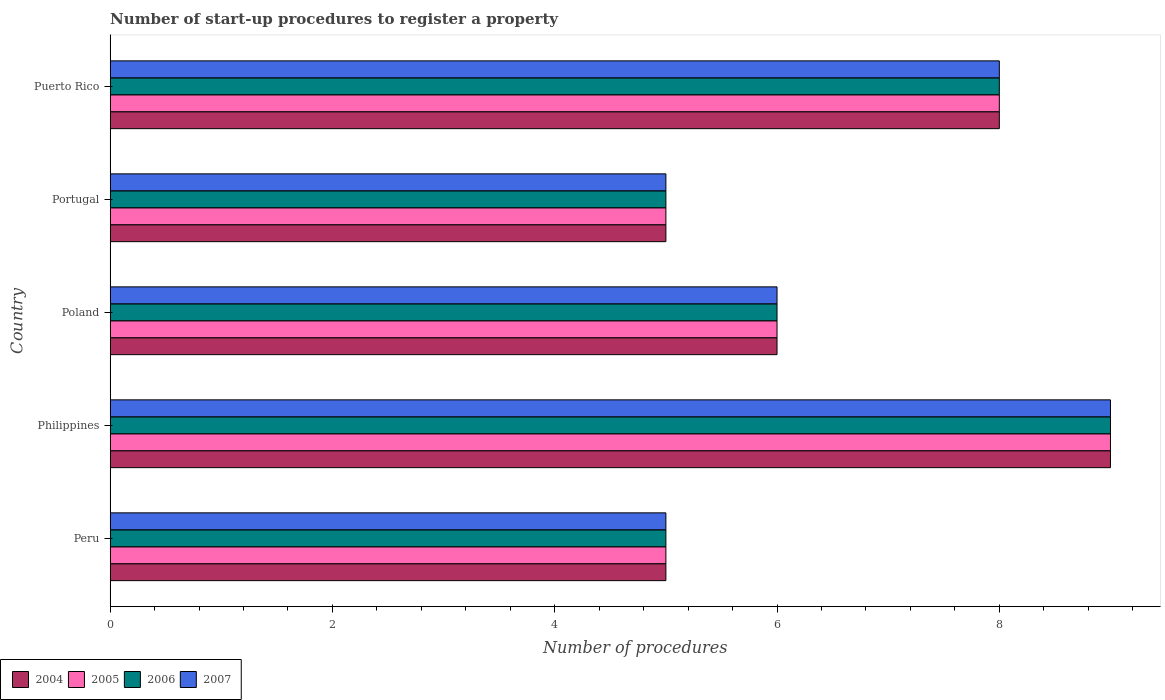How many groups of bars are there?
Give a very brief answer. 5. Are the number of bars on each tick of the Y-axis equal?
Offer a terse response. Yes. How many bars are there on the 3rd tick from the top?
Ensure brevity in your answer.  4. How many bars are there on the 5th tick from the bottom?
Offer a very short reply. 4. What is the number of procedures required to register a property in 2006 in Peru?
Keep it short and to the point. 5. In which country was the number of procedures required to register a property in 2004 maximum?
Offer a very short reply. Philippines. In which country was the number of procedures required to register a property in 2007 minimum?
Provide a succinct answer. Peru. What is the difference between the number of procedures required to register a property in 2004 and number of procedures required to register a property in 2007 in Peru?
Your answer should be very brief. 0. Is the number of procedures required to register a property in 2006 in Philippines less than that in Portugal?
Offer a terse response. No. Is the sum of the number of procedures required to register a property in 2005 in Philippines and Puerto Rico greater than the maximum number of procedures required to register a property in 2006 across all countries?
Provide a short and direct response. Yes. What does the 4th bar from the top in Portugal represents?
Offer a terse response. 2004. What does the 1st bar from the bottom in Portugal represents?
Ensure brevity in your answer.  2004. Is it the case that in every country, the sum of the number of procedures required to register a property in 2005 and number of procedures required to register a property in 2006 is greater than the number of procedures required to register a property in 2007?
Offer a very short reply. Yes. How many countries are there in the graph?
Give a very brief answer. 5. Does the graph contain any zero values?
Provide a succinct answer. No. Where does the legend appear in the graph?
Make the answer very short. Bottom left. How many legend labels are there?
Ensure brevity in your answer.  4. How are the legend labels stacked?
Give a very brief answer. Horizontal. What is the title of the graph?
Your answer should be very brief. Number of start-up procedures to register a property. What is the label or title of the X-axis?
Your answer should be compact. Number of procedures. What is the Number of procedures of 2007 in Peru?
Make the answer very short. 5. What is the Number of procedures of 2005 in Philippines?
Keep it short and to the point. 9. What is the Number of procedures in 2007 in Philippines?
Keep it short and to the point. 9. What is the Number of procedures of 2004 in Poland?
Give a very brief answer. 6. What is the Number of procedures in 2005 in Poland?
Offer a terse response. 6. What is the Number of procedures of 2004 in Portugal?
Your answer should be very brief. 5. What is the Number of procedures in 2006 in Portugal?
Your response must be concise. 5. What is the Number of procedures of 2004 in Puerto Rico?
Keep it short and to the point. 8. What is the Number of procedures of 2006 in Puerto Rico?
Your answer should be very brief. 8. What is the Number of procedures of 2007 in Puerto Rico?
Your answer should be compact. 8. Across all countries, what is the maximum Number of procedures of 2005?
Ensure brevity in your answer.  9. Across all countries, what is the minimum Number of procedures in 2004?
Ensure brevity in your answer.  5. Across all countries, what is the minimum Number of procedures of 2006?
Offer a terse response. 5. Across all countries, what is the minimum Number of procedures of 2007?
Offer a very short reply. 5. What is the total Number of procedures in 2007 in the graph?
Provide a short and direct response. 33. What is the difference between the Number of procedures in 2004 in Peru and that in Philippines?
Your response must be concise. -4. What is the difference between the Number of procedures of 2005 in Peru and that in Philippines?
Offer a terse response. -4. What is the difference between the Number of procedures of 2006 in Peru and that in Philippines?
Make the answer very short. -4. What is the difference between the Number of procedures in 2007 in Peru and that in Philippines?
Provide a succinct answer. -4. What is the difference between the Number of procedures in 2005 in Peru and that in Poland?
Offer a very short reply. -1. What is the difference between the Number of procedures of 2007 in Peru and that in Poland?
Offer a terse response. -1. What is the difference between the Number of procedures in 2005 in Peru and that in Portugal?
Provide a succinct answer. 0. What is the difference between the Number of procedures of 2006 in Peru and that in Portugal?
Your answer should be very brief. 0. What is the difference between the Number of procedures in 2005 in Philippines and that in Poland?
Your response must be concise. 3. What is the difference between the Number of procedures of 2006 in Philippines and that in Poland?
Keep it short and to the point. 3. What is the difference between the Number of procedures in 2005 in Philippines and that in Puerto Rico?
Your response must be concise. 1. What is the difference between the Number of procedures in 2006 in Philippines and that in Puerto Rico?
Provide a short and direct response. 1. What is the difference between the Number of procedures of 2007 in Philippines and that in Puerto Rico?
Your answer should be compact. 1. What is the difference between the Number of procedures of 2004 in Poland and that in Portugal?
Provide a succinct answer. 1. What is the difference between the Number of procedures in 2005 in Poland and that in Portugal?
Your answer should be very brief. 1. What is the difference between the Number of procedures of 2006 in Poland and that in Portugal?
Your response must be concise. 1. What is the difference between the Number of procedures in 2004 in Poland and that in Puerto Rico?
Keep it short and to the point. -2. What is the difference between the Number of procedures of 2005 in Poland and that in Puerto Rico?
Ensure brevity in your answer.  -2. What is the difference between the Number of procedures in 2006 in Poland and that in Puerto Rico?
Offer a terse response. -2. What is the difference between the Number of procedures in 2004 in Portugal and that in Puerto Rico?
Your response must be concise. -3. What is the difference between the Number of procedures of 2005 in Portugal and that in Puerto Rico?
Provide a succinct answer. -3. What is the difference between the Number of procedures in 2006 in Portugal and that in Puerto Rico?
Provide a succinct answer. -3. What is the difference between the Number of procedures in 2007 in Portugal and that in Puerto Rico?
Give a very brief answer. -3. What is the difference between the Number of procedures in 2004 in Peru and the Number of procedures in 2007 in Philippines?
Keep it short and to the point. -4. What is the difference between the Number of procedures in 2005 in Peru and the Number of procedures in 2007 in Philippines?
Your response must be concise. -4. What is the difference between the Number of procedures in 2006 in Peru and the Number of procedures in 2007 in Philippines?
Offer a very short reply. -4. What is the difference between the Number of procedures of 2004 in Peru and the Number of procedures of 2007 in Poland?
Provide a succinct answer. -1. What is the difference between the Number of procedures of 2005 in Peru and the Number of procedures of 2006 in Poland?
Offer a terse response. -1. What is the difference between the Number of procedures in 2005 in Peru and the Number of procedures in 2007 in Poland?
Your response must be concise. -1. What is the difference between the Number of procedures of 2006 in Peru and the Number of procedures of 2007 in Poland?
Provide a short and direct response. -1. What is the difference between the Number of procedures of 2004 in Peru and the Number of procedures of 2005 in Portugal?
Offer a terse response. 0. What is the difference between the Number of procedures of 2004 in Peru and the Number of procedures of 2007 in Portugal?
Make the answer very short. 0. What is the difference between the Number of procedures of 2005 in Peru and the Number of procedures of 2006 in Portugal?
Your answer should be very brief. 0. What is the difference between the Number of procedures of 2005 in Peru and the Number of procedures of 2007 in Portugal?
Offer a very short reply. 0. What is the difference between the Number of procedures of 2006 in Peru and the Number of procedures of 2007 in Portugal?
Offer a very short reply. 0. What is the difference between the Number of procedures of 2004 in Peru and the Number of procedures of 2006 in Puerto Rico?
Offer a terse response. -3. What is the difference between the Number of procedures in 2004 in Philippines and the Number of procedures in 2005 in Poland?
Keep it short and to the point. 3. What is the difference between the Number of procedures of 2004 in Philippines and the Number of procedures of 2006 in Poland?
Your answer should be compact. 3. What is the difference between the Number of procedures in 2005 in Philippines and the Number of procedures in 2006 in Poland?
Offer a very short reply. 3. What is the difference between the Number of procedures of 2004 in Philippines and the Number of procedures of 2005 in Portugal?
Give a very brief answer. 4. What is the difference between the Number of procedures in 2004 in Philippines and the Number of procedures in 2006 in Portugal?
Your answer should be compact. 4. What is the difference between the Number of procedures of 2004 in Philippines and the Number of procedures of 2007 in Portugal?
Offer a very short reply. 4. What is the difference between the Number of procedures of 2005 in Philippines and the Number of procedures of 2007 in Portugal?
Make the answer very short. 4. What is the difference between the Number of procedures in 2006 in Philippines and the Number of procedures in 2007 in Portugal?
Make the answer very short. 4. What is the difference between the Number of procedures of 2004 in Philippines and the Number of procedures of 2006 in Puerto Rico?
Your response must be concise. 1. What is the difference between the Number of procedures of 2005 in Philippines and the Number of procedures of 2006 in Puerto Rico?
Your response must be concise. 1. What is the difference between the Number of procedures of 2004 in Poland and the Number of procedures of 2005 in Portugal?
Give a very brief answer. 1. What is the difference between the Number of procedures of 2004 in Poland and the Number of procedures of 2006 in Portugal?
Offer a very short reply. 1. What is the difference between the Number of procedures of 2005 in Poland and the Number of procedures of 2007 in Portugal?
Give a very brief answer. 1. What is the difference between the Number of procedures of 2004 in Poland and the Number of procedures of 2005 in Puerto Rico?
Your answer should be compact. -2. What is the difference between the Number of procedures in 2004 in Poland and the Number of procedures in 2006 in Puerto Rico?
Your answer should be compact. -2. What is the difference between the Number of procedures of 2006 in Poland and the Number of procedures of 2007 in Puerto Rico?
Make the answer very short. -2. What is the difference between the Number of procedures of 2004 in Portugal and the Number of procedures of 2005 in Puerto Rico?
Provide a short and direct response. -3. What is the difference between the Number of procedures in 2004 in Portugal and the Number of procedures in 2006 in Puerto Rico?
Provide a short and direct response. -3. What is the difference between the Number of procedures of 2004 in Portugal and the Number of procedures of 2007 in Puerto Rico?
Offer a very short reply. -3. What is the difference between the Number of procedures of 2005 in Portugal and the Number of procedures of 2006 in Puerto Rico?
Make the answer very short. -3. What is the average Number of procedures in 2004 per country?
Your answer should be compact. 6.6. What is the average Number of procedures in 2005 per country?
Provide a short and direct response. 6.6. What is the average Number of procedures in 2006 per country?
Your response must be concise. 6.6. What is the difference between the Number of procedures of 2004 and Number of procedures of 2007 in Peru?
Your answer should be very brief. 0. What is the difference between the Number of procedures in 2005 and Number of procedures in 2006 in Peru?
Offer a very short reply. 0. What is the difference between the Number of procedures in 2004 and Number of procedures in 2005 in Philippines?
Keep it short and to the point. 0. What is the difference between the Number of procedures in 2004 and Number of procedures in 2007 in Philippines?
Give a very brief answer. 0. What is the difference between the Number of procedures in 2005 and Number of procedures in 2006 in Philippines?
Offer a terse response. 0. What is the difference between the Number of procedures of 2004 and Number of procedures of 2005 in Poland?
Your response must be concise. 0. What is the difference between the Number of procedures in 2004 and Number of procedures in 2006 in Poland?
Ensure brevity in your answer.  0. What is the difference between the Number of procedures of 2004 and Number of procedures of 2007 in Poland?
Provide a short and direct response. 0. What is the difference between the Number of procedures in 2005 and Number of procedures in 2006 in Poland?
Keep it short and to the point. 0. What is the difference between the Number of procedures in 2005 and Number of procedures in 2007 in Portugal?
Provide a short and direct response. 0. What is the difference between the Number of procedures of 2006 and Number of procedures of 2007 in Portugal?
Make the answer very short. 0. What is the difference between the Number of procedures of 2004 and Number of procedures of 2005 in Puerto Rico?
Provide a succinct answer. 0. What is the difference between the Number of procedures in 2004 and Number of procedures in 2006 in Puerto Rico?
Provide a succinct answer. 0. What is the difference between the Number of procedures in 2005 and Number of procedures in 2006 in Puerto Rico?
Your response must be concise. 0. What is the difference between the Number of procedures of 2005 and Number of procedures of 2007 in Puerto Rico?
Keep it short and to the point. 0. What is the ratio of the Number of procedures of 2004 in Peru to that in Philippines?
Make the answer very short. 0.56. What is the ratio of the Number of procedures in 2005 in Peru to that in Philippines?
Your answer should be compact. 0.56. What is the ratio of the Number of procedures of 2006 in Peru to that in Philippines?
Your answer should be compact. 0.56. What is the ratio of the Number of procedures in 2007 in Peru to that in Philippines?
Your response must be concise. 0.56. What is the ratio of the Number of procedures of 2005 in Peru to that in Poland?
Give a very brief answer. 0.83. What is the ratio of the Number of procedures in 2006 in Peru to that in Portugal?
Your answer should be compact. 1. What is the ratio of the Number of procedures of 2007 in Peru to that in Portugal?
Offer a very short reply. 1. What is the ratio of the Number of procedures in 2005 in Peru to that in Puerto Rico?
Keep it short and to the point. 0.62. What is the ratio of the Number of procedures of 2007 in Peru to that in Puerto Rico?
Provide a short and direct response. 0.62. What is the ratio of the Number of procedures in 2004 in Philippines to that in Poland?
Provide a succinct answer. 1.5. What is the ratio of the Number of procedures in 2005 in Philippines to that in Poland?
Keep it short and to the point. 1.5. What is the ratio of the Number of procedures in 2007 in Philippines to that in Poland?
Offer a terse response. 1.5. What is the ratio of the Number of procedures of 2004 in Philippines to that in Portugal?
Provide a short and direct response. 1.8. What is the ratio of the Number of procedures of 2006 in Philippines to that in Portugal?
Ensure brevity in your answer.  1.8. What is the ratio of the Number of procedures in 2007 in Philippines to that in Portugal?
Your response must be concise. 1.8. What is the ratio of the Number of procedures in 2006 in Poland to that in Portugal?
Ensure brevity in your answer.  1.2. What is the ratio of the Number of procedures of 2006 in Poland to that in Puerto Rico?
Provide a succinct answer. 0.75. What is the ratio of the Number of procedures in 2006 in Portugal to that in Puerto Rico?
Provide a succinct answer. 0.62. What is the difference between the highest and the second highest Number of procedures of 2004?
Your answer should be compact. 1. What is the difference between the highest and the second highest Number of procedures in 2006?
Offer a very short reply. 1. What is the difference between the highest and the lowest Number of procedures of 2004?
Provide a short and direct response. 4. What is the difference between the highest and the lowest Number of procedures in 2005?
Provide a short and direct response. 4. What is the difference between the highest and the lowest Number of procedures in 2006?
Ensure brevity in your answer.  4. What is the difference between the highest and the lowest Number of procedures of 2007?
Offer a terse response. 4. 